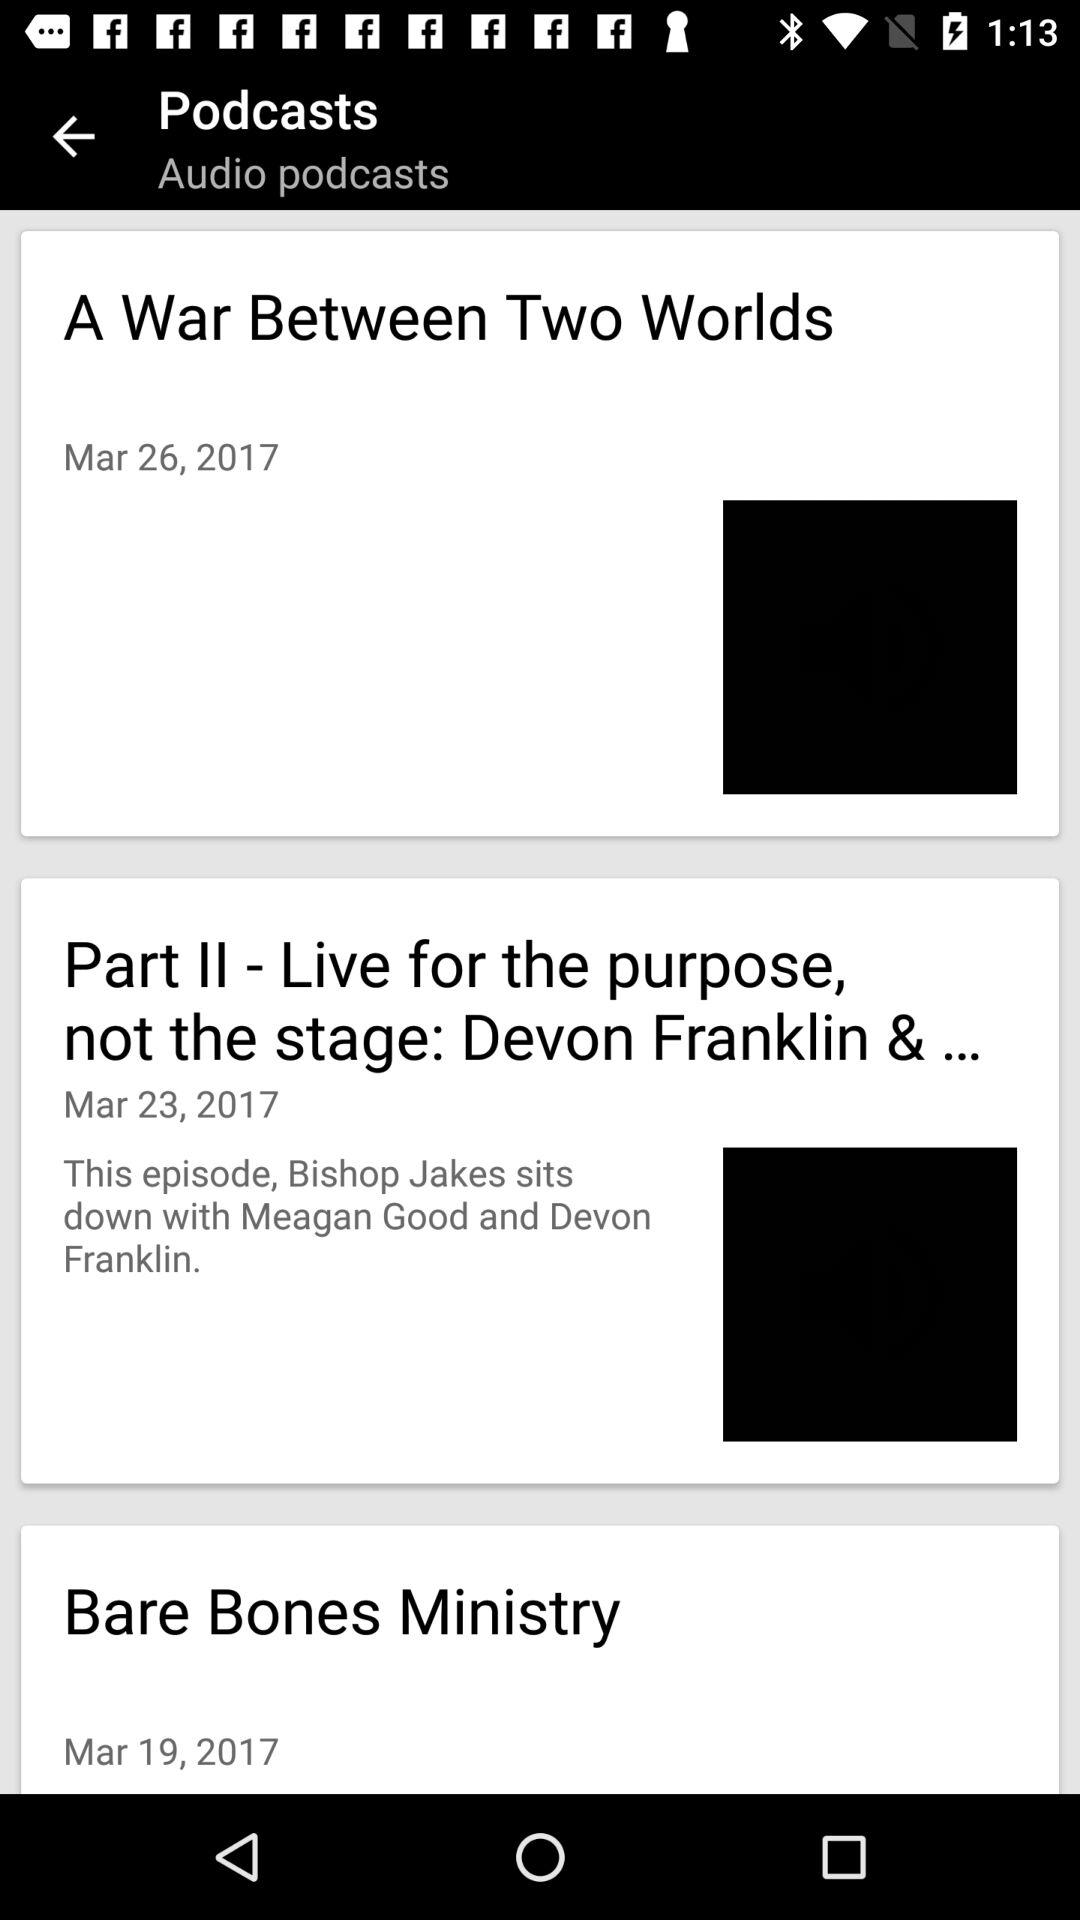How many podcasts are there?
Answer the question using a single word or phrase. 3 